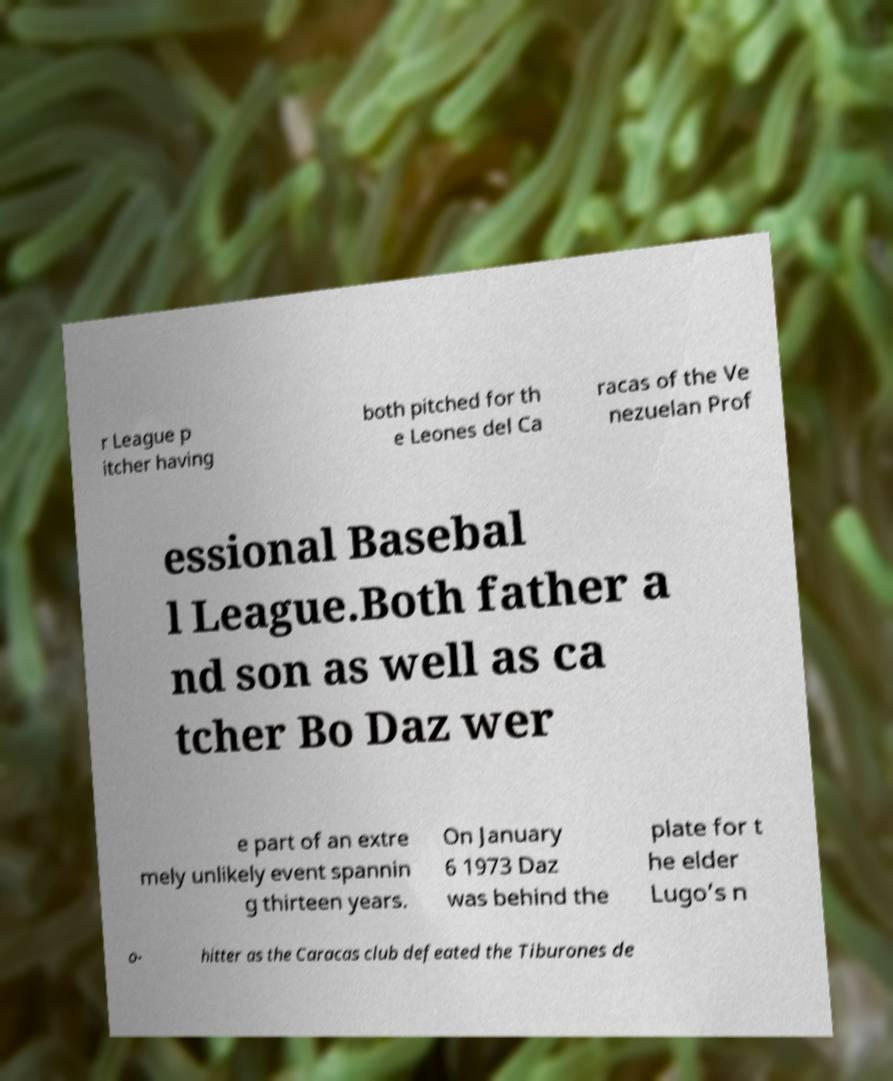For documentation purposes, I need the text within this image transcribed. Could you provide that? r League p itcher having both pitched for th e Leones del Ca racas of the Ve nezuelan Prof essional Basebal l League.Both father a nd son as well as ca tcher Bo Daz wer e part of an extre mely unlikely event spannin g thirteen years. On January 6 1973 Daz was behind the plate for t he elder Lugo’s n o- hitter as the Caracas club defeated the Tiburones de 